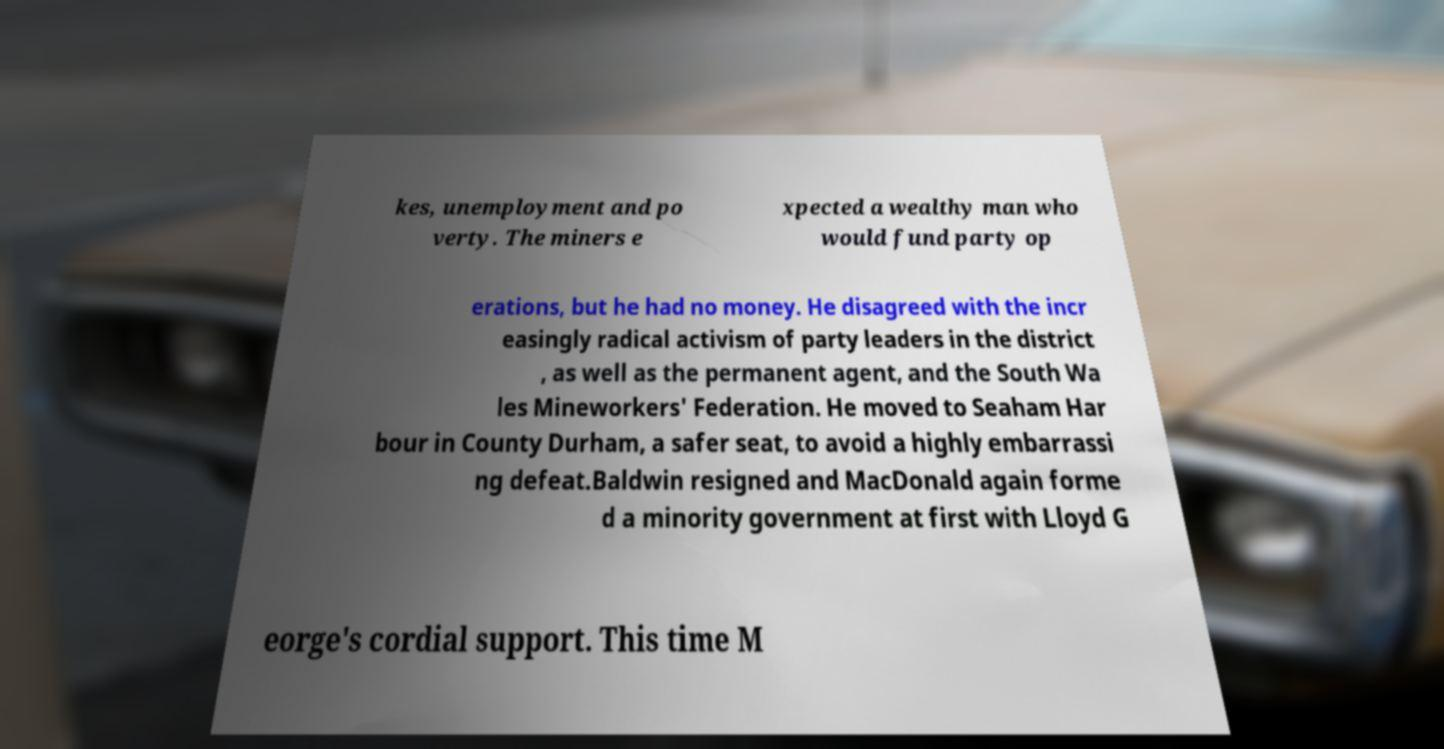Could you extract and type out the text from this image? kes, unemployment and po verty. The miners e xpected a wealthy man who would fund party op erations, but he had no money. He disagreed with the incr easingly radical activism of party leaders in the district , as well as the permanent agent, and the South Wa les Mineworkers' Federation. He moved to Seaham Har bour in County Durham, a safer seat, to avoid a highly embarrassi ng defeat.Baldwin resigned and MacDonald again forme d a minority government at first with Lloyd G eorge's cordial support. This time M 